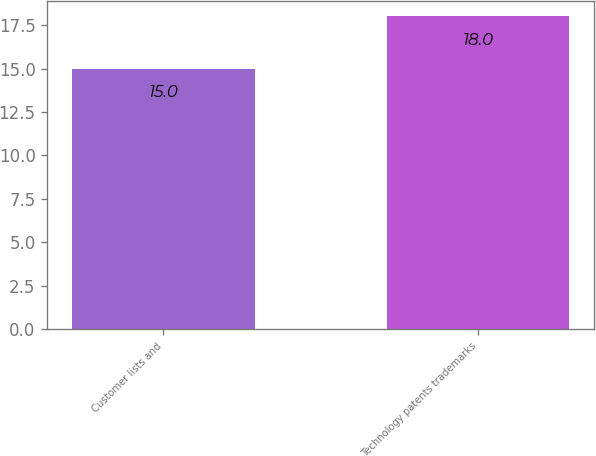<chart> <loc_0><loc_0><loc_500><loc_500><bar_chart><fcel>Customer lists and<fcel>Technology patents trademarks<nl><fcel>15<fcel>18<nl></chart> 